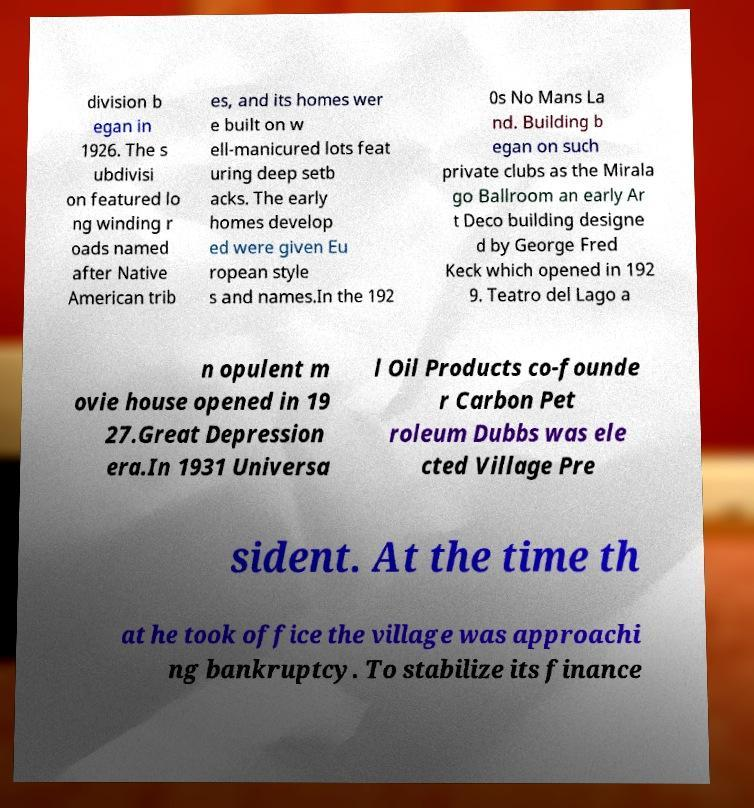Can you read and provide the text displayed in the image?This photo seems to have some interesting text. Can you extract and type it out for me? division b egan in 1926. The s ubdivisi on featured lo ng winding r oads named after Native American trib es, and its homes wer e built on w ell-manicured lots feat uring deep setb acks. The early homes develop ed were given Eu ropean style s and names.In the 192 0s No Mans La nd. Building b egan on such private clubs as the Mirala go Ballroom an early Ar t Deco building designe d by George Fred Keck which opened in 192 9. Teatro del Lago a n opulent m ovie house opened in 19 27.Great Depression era.In 1931 Universa l Oil Products co-founde r Carbon Pet roleum Dubbs was ele cted Village Pre sident. At the time th at he took office the village was approachi ng bankruptcy. To stabilize its finance 